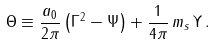Convert formula to latex. <formula><loc_0><loc_0><loc_500><loc_500>\Theta \equiv \frac { a _ { 0 } } { 2 \pi } \left ( \Gamma ^ { 2 } - \Psi \right ) + \frac { 1 } { 4 \pi } \, m _ { s } \, \Upsilon \, .</formula> 